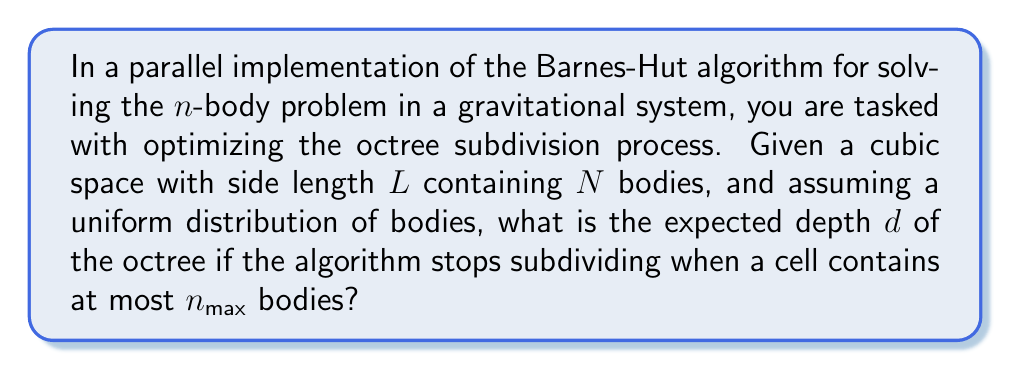Solve this math problem. To solve this problem, we need to follow these steps:

1) In the Barnes-Hut algorithm, space is recursively divided into octants until each cell contains at most $n_{max}$ bodies.

2) At each level of the octree, the volume of a cell is reduced by a factor of 8. Therefore, the volume $V_d$ at depth $d$ is:

   $$V_d = \frac{L^3}{8^d}$$

3) Assuming uniform distribution, the number of bodies in a cell at depth $d$ is proportional to its volume. We can express this as:

   $$\frac{N}{L^3} = \frac{n_{max}}{V_d}$$

4) Substituting the expression for $V_d$:

   $$\frac{N}{L^3} = \frac{n_{max}}{\frac{L^3}{8^d}}$$

5) Simplifying:

   $$N = n_{max} \cdot 8^d$$

6) Taking the logarithm of both sides:

   $$\log N = \log n_{max} + d \log 8$$

7) Solving for $d$:

   $$d = \frac{\log N - \log n_{max}}{\log 8}$$

8) Since $\log 8 = 3 \log 2$, we can rewrite this as:

   $$d = \frac{\log N - \log n_{max}}{3 \log 2}$$

This gives us the expected depth of the octree.
Answer: The expected depth $d$ of the octree is:

$$d = \frac{\log N - \log n_{max}}{3 \log 2}$$

where $N$ is the total number of bodies and $n_{max}$ is the maximum number of bodies per cell. 